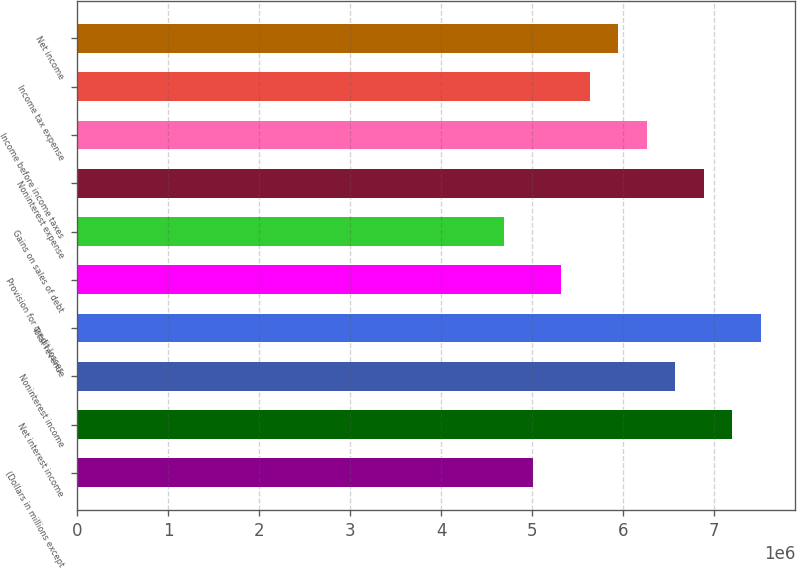<chart> <loc_0><loc_0><loc_500><loc_500><bar_chart><fcel>(Dollars in millions except<fcel>Net interest income<fcel>Noninterest income<fcel>Total revenue<fcel>Provision for credit losses<fcel>Gains on sales of debt<fcel>Noninterest expense<fcel>Income before income taxes<fcel>Income tax expense<fcel>Net income<nl><fcel>5.0095e+06<fcel>7.20115e+06<fcel>6.57496e+06<fcel>7.51424e+06<fcel>5.32259e+06<fcel>4.6964e+06<fcel>6.88806e+06<fcel>6.26187e+06<fcel>5.63568e+06<fcel>5.94878e+06<nl></chart> 